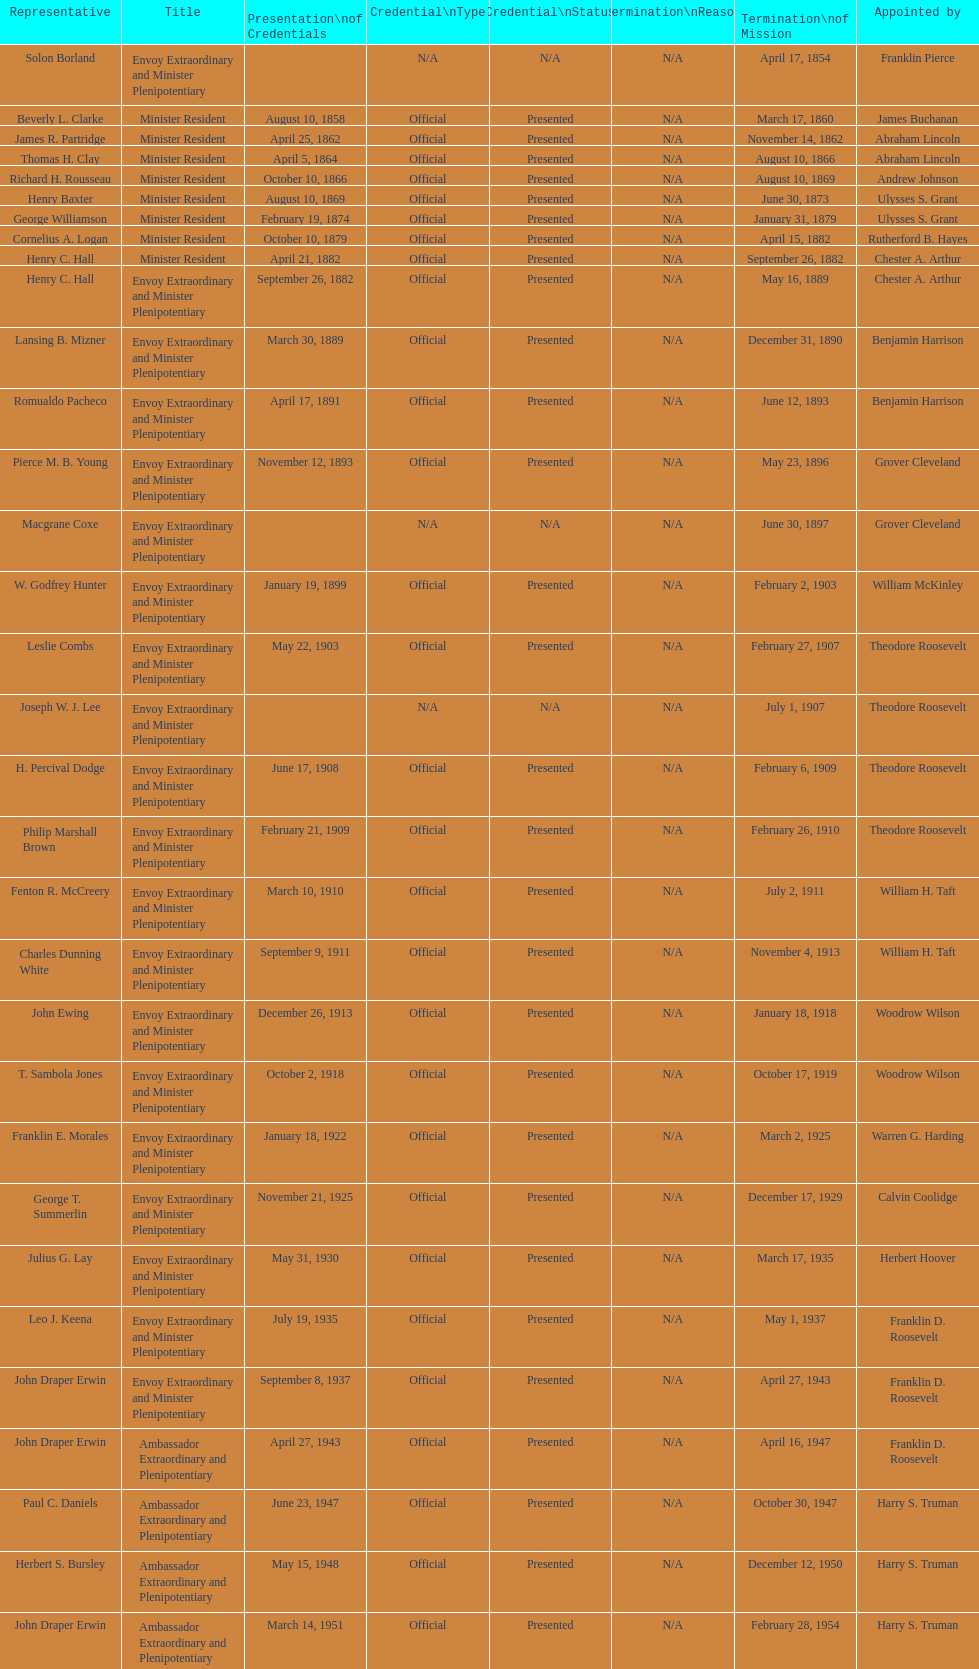Who became the ambassador after the completion of hewson ryan's mission? Phillip V. Sanchez. 